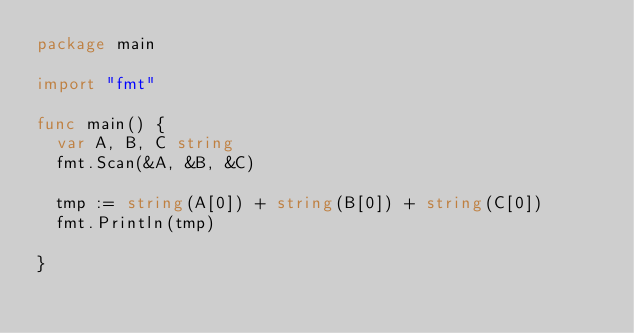<code> <loc_0><loc_0><loc_500><loc_500><_Go_>package main

import "fmt"

func main() {
	var A, B, C string
	fmt.Scan(&A, &B, &C)

	tmp := string(A[0]) + string(B[0]) + string(C[0])
	fmt.Println(tmp)

}
</code> 